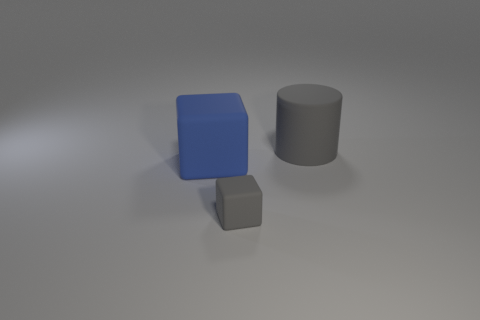Add 3 tiny gray objects. How many objects exist? 6 Subtract all cylinders. How many objects are left? 2 Add 2 rubber things. How many rubber things are left? 5 Add 2 big blue rubber things. How many big blue rubber things exist? 3 Subtract 0 red blocks. How many objects are left? 3 Subtract all large cubes. Subtract all gray matte cylinders. How many objects are left? 1 